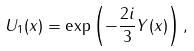Convert formula to latex. <formula><loc_0><loc_0><loc_500><loc_500>U _ { 1 } ( x ) = \exp \left ( - \frac { 2 i } { 3 } Y ( x ) \right ) ,</formula> 